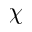<formula> <loc_0><loc_0><loc_500><loc_500>\chi</formula> 